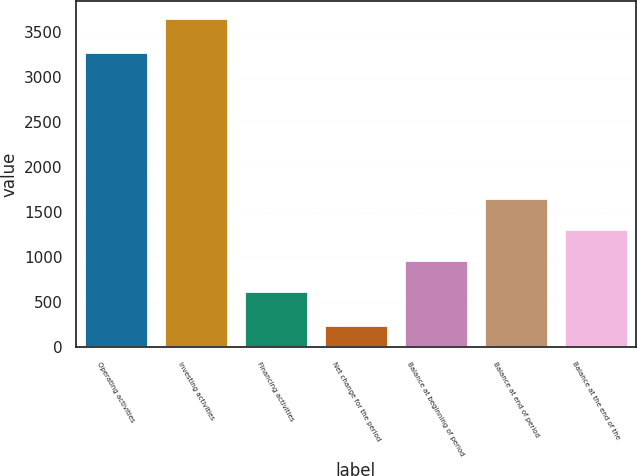Convert chart. <chart><loc_0><loc_0><loc_500><loc_500><bar_chart><fcel>Operating activities<fcel>Investing activities<fcel>Financing activities<fcel>Net change for the period<fcel>Balance at beginning of period<fcel>Balance at end of period<fcel>Balance at the end of the<nl><fcel>3277<fcel>3657<fcel>629<fcel>249<fcel>969.8<fcel>1651.4<fcel>1310.6<nl></chart> 